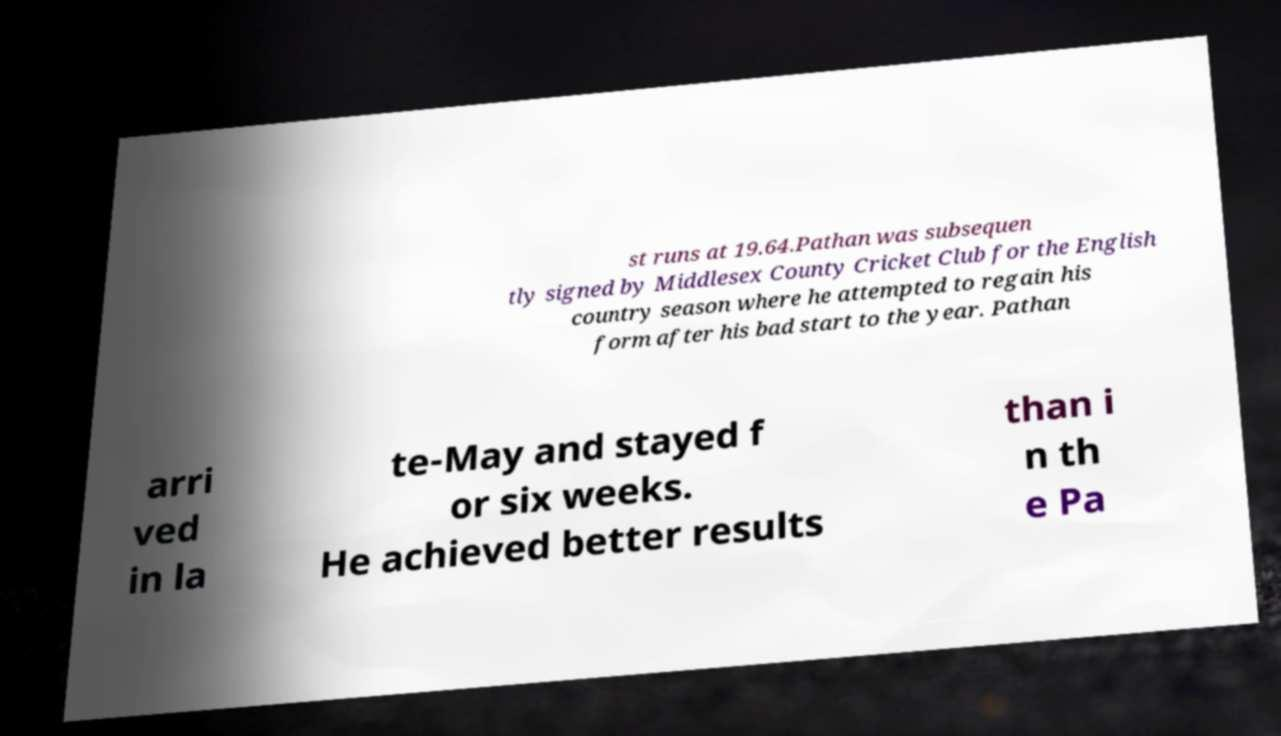What messages or text are displayed in this image? I need them in a readable, typed format. st runs at 19.64.Pathan was subsequen tly signed by Middlesex County Cricket Club for the English country season where he attempted to regain his form after his bad start to the year. Pathan arri ved in la te-May and stayed f or six weeks. He achieved better results than i n th e Pa 